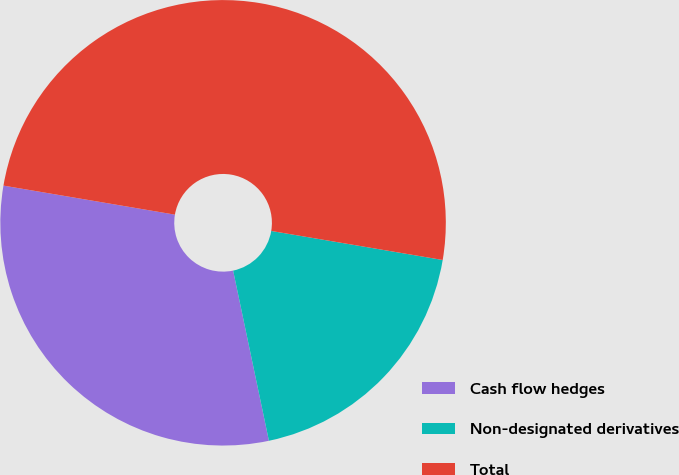<chart> <loc_0><loc_0><loc_500><loc_500><pie_chart><fcel>Cash flow hedges<fcel>Non-designated derivatives<fcel>Total<nl><fcel>30.97%<fcel>19.03%<fcel>50.0%<nl></chart> 